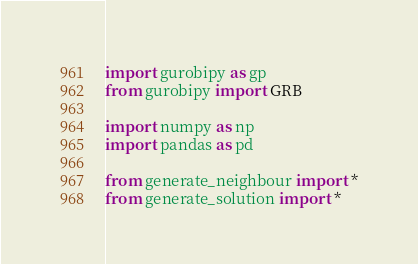<code> <loc_0><loc_0><loc_500><loc_500><_Python_>

import gurobipy as gp
from gurobipy import GRB

import numpy as np
import pandas as pd

from generate_neighbour import *
from generate_solution import *
</code> 